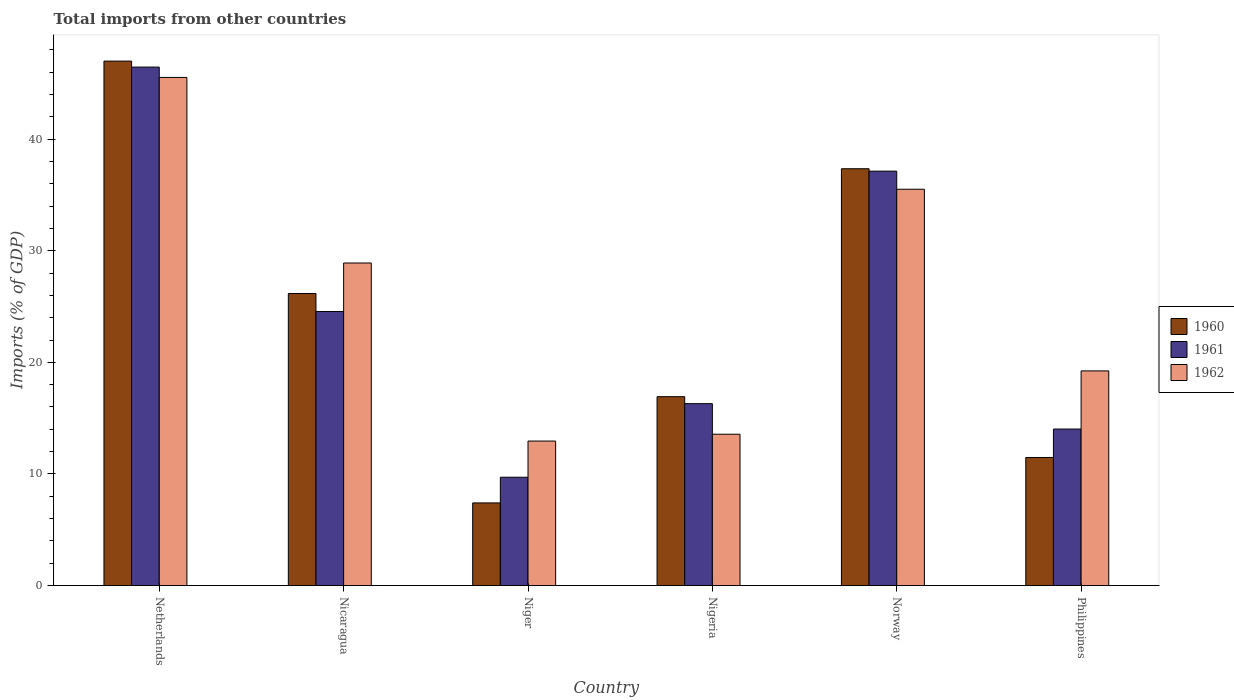What is the total imports in 1962 in Philippines?
Your answer should be very brief. 19.23. Across all countries, what is the maximum total imports in 1960?
Provide a short and direct response. 46.99. Across all countries, what is the minimum total imports in 1962?
Keep it short and to the point. 12.95. In which country was the total imports in 1961 minimum?
Provide a short and direct response. Niger. What is the total total imports in 1960 in the graph?
Your answer should be compact. 146.32. What is the difference between the total imports in 1962 in Nicaragua and that in Nigeria?
Provide a short and direct response. 15.34. What is the difference between the total imports in 1962 in Nigeria and the total imports in 1961 in Niger?
Keep it short and to the point. 3.86. What is the average total imports in 1960 per country?
Your answer should be very brief. 24.39. What is the difference between the total imports of/in 1962 and total imports of/in 1960 in Nicaragua?
Ensure brevity in your answer.  2.73. In how many countries, is the total imports in 1960 greater than 8 %?
Offer a very short reply. 5. What is the ratio of the total imports in 1962 in Nigeria to that in Philippines?
Your response must be concise. 0.7. Is the total imports in 1962 in Netherlands less than that in Nigeria?
Your answer should be compact. No. What is the difference between the highest and the second highest total imports in 1962?
Ensure brevity in your answer.  6.61. What is the difference between the highest and the lowest total imports in 1960?
Ensure brevity in your answer.  39.59. Is the sum of the total imports in 1962 in Nigeria and Norway greater than the maximum total imports in 1960 across all countries?
Make the answer very short. Yes. How many countries are there in the graph?
Your response must be concise. 6. Are the values on the major ticks of Y-axis written in scientific E-notation?
Give a very brief answer. No. Does the graph contain any zero values?
Provide a short and direct response. No. Does the graph contain grids?
Provide a short and direct response. No. How many legend labels are there?
Give a very brief answer. 3. What is the title of the graph?
Offer a terse response. Total imports from other countries. What is the label or title of the X-axis?
Ensure brevity in your answer.  Country. What is the label or title of the Y-axis?
Offer a very short reply. Imports (% of GDP). What is the Imports (% of GDP) in 1960 in Netherlands?
Ensure brevity in your answer.  46.99. What is the Imports (% of GDP) in 1961 in Netherlands?
Provide a succinct answer. 46.46. What is the Imports (% of GDP) of 1962 in Netherlands?
Offer a very short reply. 45.53. What is the Imports (% of GDP) of 1960 in Nicaragua?
Your answer should be very brief. 26.17. What is the Imports (% of GDP) in 1961 in Nicaragua?
Keep it short and to the point. 24.55. What is the Imports (% of GDP) in 1962 in Nicaragua?
Your answer should be compact. 28.9. What is the Imports (% of GDP) in 1960 in Niger?
Provide a succinct answer. 7.41. What is the Imports (% of GDP) in 1961 in Niger?
Offer a very short reply. 9.71. What is the Imports (% of GDP) of 1962 in Niger?
Give a very brief answer. 12.95. What is the Imports (% of GDP) of 1960 in Nigeria?
Give a very brief answer. 16.92. What is the Imports (% of GDP) in 1961 in Nigeria?
Offer a very short reply. 16.3. What is the Imports (% of GDP) in 1962 in Nigeria?
Make the answer very short. 13.56. What is the Imports (% of GDP) of 1960 in Norway?
Offer a very short reply. 37.35. What is the Imports (% of GDP) in 1961 in Norway?
Your answer should be very brief. 37.13. What is the Imports (% of GDP) in 1962 in Norway?
Offer a very short reply. 35.51. What is the Imports (% of GDP) in 1960 in Philippines?
Keep it short and to the point. 11.48. What is the Imports (% of GDP) of 1961 in Philippines?
Your answer should be compact. 14.02. What is the Imports (% of GDP) in 1962 in Philippines?
Your answer should be very brief. 19.23. Across all countries, what is the maximum Imports (% of GDP) in 1960?
Offer a terse response. 46.99. Across all countries, what is the maximum Imports (% of GDP) in 1961?
Offer a terse response. 46.46. Across all countries, what is the maximum Imports (% of GDP) in 1962?
Provide a short and direct response. 45.53. Across all countries, what is the minimum Imports (% of GDP) of 1960?
Provide a succinct answer. 7.41. Across all countries, what is the minimum Imports (% of GDP) in 1961?
Make the answer very short. 9.71. Across all countries, what is the minimum Imports (% of GDP) in 1962?
Provide a short and direct response. 12.95. What is the total Imports (% of GDP) of 1960 in the graph?
Keep it short and to the point. 146.32. What is the total Imports (% of GDP) in 1961 in the graph?
Provide a succinct answer. 148.17. What is the total Imports (% of GDP) of 1962 in the graph?
Offer a very short reply. 155.69. What is the difference between the Imports (% of GDP) in 1960 in Netherlands and that in Nicaragua?
Make the answer very short. 20.82. What is the difference between the Imports (% of GDP) of 1961 in Netherlands and that in Nicaragua?
Keep it short and to the point. 21.9. What is the difference between the Imports (% of GDP) in 1962 in Netherlands and that in Nicaragua?
Ensure brevity in your answer.  16.63. What is the difference between the Imports (% of GDP) in 1960 in Netherlands and that in Niger?
Ensure brevity in your answer.  39.59. What is the difference between the Imports (% of GDP) in 1961 in Netherlands and that in Niger?
Provide a short and direct response. 36.75. What is the difference between the Imports (% of GDP) of 1962 in Netherlands and that in Niger?
Ensure brevity in your answer.  32.58. What is the difference between the Imports (% of GDP) of 1960 in Netherlands and that in Nigeria?
Provide a succinct answer. 30.07. What is the difference between the Imports (% of GDP) in 1961 in Netherlands and that in Nigeria?
Provide a short and direct response. 30.16. What is the difference between the Imports (% of GDP) of 1962 in Netherlands and that in Nigeria?
Your answer should be compact. 31.97. What is the difference between the Imports (% of GDP) of 1960 in Netherlands and that in Norway?
Your answer should be very brief. 9.64. What is the difference between the Imports (% of GDP) of 1961 in Netherlands and that in Norway?
Keep it short and to the point. 9.32. What is the difference between the Imports (% of GDP) in 1962 in Netherlands and that in Norway?
Offer a very short reply. 10.02. What is the difference between the Imports (% of GDP) of 1960 in Netherlands and that in Philippines?
Offer a terse response. 35.52. What is the difference between the Imports (% of GDP) in 1961 in Netherlands and that in Philippines?
Provide a succinct answer. 32.43. What is the difference between the Imports (% of GDP) in 1962 in Netherlands and that in Philippines?
Offer a very short reply. 26.29. What is the difference between the Imports (% of GDP) in 1960 in Nicaragua and that in Niger?
Offer a very short reply. 18.76. What is the difference between the Imports (% of GDP) of 1961 in Nicaragua and that in Niger?
Give a very brief answer. 14.85. What is the difference between the Imports (% of GDP) of 1962 in Nicaragua and that in Niger?
Make the answer very short. 15.96. What is the difference between the Imports (% of GDP) of 1960 in Nicaragua and that in Nigeria?
Your answer should be compact. 9.24. What is the difference between the Imports (% of GDP) in 1961 in Nicaragua and that in Nigeria?
Keep it short and to the point. 8.25. What is the difference between the Imports (% of GDP) in 1962 in Nicaragua and that in Nigeria?
Your response must be concise. 15.34. What is the difference between the Imports (% of GDP) of 1960 in Nicaragua and that in Norway?
Offer a terse response. -11.18. What is the difference between the Imports (% of GDP) of 1961 in Nicaragua and that in Norway?
Your response must be concise. -12.58. What is the difference between the Imports (% of GDP) in 1962 in Nicaragua and that in Norway?
Provide a short and direct response. -6.61. What is the difference between the Imports (% of GDP) in 1960 in Nicaragua and that in Philippines?
Offer a terse response. 14.69. What is the difference between the Imports (% of GDP) of 1961 in Nicaragua and that in Philippines?
Keep it short and to the point. 10.53. What is the difference between the Imports (% of GDP) of 1962 in Nicaragua and that in Philippines?
Your answer should be very brief. 9.67. What is the difference between the Imports (% of GDP) in 1960 in Niger and that in Nigeria?
Make the answer very short. -9.52. What is the difference between the Imports (% of GDP) in 1961 in Niger and that in Nigeria?
Keep it short and to the point. -6.59. What is the difference between the Imports (% of GDP) in 1962 in Niger and that in Nigeria?
Offer a very short reply. -0.61. What is the difference between the Imports (% of GDP) in 1960 in Niger and that in Norway?
Your answer should be compact. -29.94. What is the difference between the Imports (% of GDP) of 1961 in Niger and that in Norway?
Provide a short and direct response. -27.43. What is the difference between the Imports (% of GDP) of 1962 in Niger and that in Norway?
Offer a terse response. -22.56. What is the difference between the Imports (% of GDP) of 1960 in Niger and that in Philippines?
Your answer should be very brief. -4.07. What is the difference between the Imports (% of GDP) in 1961 in Niger and that in Philippines?
Make the answer very short. -4.32. What is the difference between the Imports (% of GDP) in 1962 in Niger and that in Philippines?
Offer a very short reply. -6.29. What is the difference between the Imports (% of GDP) in 1960 in Nigeria and that in Norway?
Keep it short and to the point. -20.42. What is the difference between the Imports (% of GDP) in 1961 in Nigeria and that in Norway?
Give a very brief answer. -20.83. What is the difference between the Imports (% of GDP) of 1962 in Nigeria and that in Norway?
Your answer should be compact. -21.95. What is the difference between the Imports (% of GDP) of 1960 in Nigeria and that in Philippines?
Provide a short and direct response. 5.45. What is the difference between the Imports (% of GDP) in 1961 in Nigeria and that in Philippines?
Your answer should be compact. 2.27. What is the difference between the Imports (% of GDP) of 1962 in Nigeria and that in Philippines?
Your answer should be very brief. -5.67. What is the difference between the Imports (% of GDP) in 1960 in Norway and that in Philippines?
Your answer should be very brief. 25.87. What is the difference between the Imports (% of GDP) in 1961 in Norway and that in Philippines?
Ensure brevity in your answer.  23.11. What is the difference between the Imports (% of GDP) of 1962 in Norway and that in Philippines?
Keep it short and to the point. 16.28. What is the difference between the Imports (% of GDP) of 1960 in Netherlands and the Imports (% of GDP) of 1961 in Nicaragua?
Your answer should be very brief. 22.44. What is the difference between the Imports (% of GDP) in 1960 in Netherlands and the Imports (% of GDP) in 1962 in Nicaragua?
Your answer should be compact. 18.09. What is the difference between the Imports (% of GDP) of 1961 in Netherlands and the Imports (% of GDP) of 1962 in Nicaragua?
Your answer should be compact. 17.55. What is the difference between the Imports (% of GDP) in 1960 in Netherlands and the Imports (% of GDP) in 1961 in Niger?
Your answer should be compact. 37.29. What is the difference between the Imports (% of GDP) in 1960 in Netherlands and the Imports (% of GDP) in 1962 in Niger?
Give a very brief answer. 34.05. What is the difference between the Imports (% of GDP) of 1961 in Netherlands and the Imports (% of GDP) of 1962 in Niger?
Provide a short and direct response. 33.51. What is the difference between the Imports (% of GDP) of 1960 in Netherlands and the Imports (% of GDP) of 1961 in Nigeria?
Your answer should be very brief. 30.69. What is the difference between the Imports (% of GDP) in 1960 in Netherlands and the Imports (% of GDP) in 1962 in Nigeria?
Offer a very short reply. 33.43. What is the difference between the Imports (% of GDP) of 1961 in Netherlands and the Imports (% of GDP) of 1962 in Nigeria?
Keep it short and to the point. 32.9. What is the difference between the Imports (% of GDP) of 1960 in Netherlands and the Imports (% of GDP) of 1961 in Norway?
Your answer should be compact. 9.86. What is the difference between the Imports (% of GDP) of 1960 in Netherlands and the Imports (% of GDP) of 1962 in Norway?
Keep it short and to the point. 11.48. What is the difference between the Imports (% of GDP) of 1961 in Netherlands and the Imports (% of GDP) of 1962 in Norway?
Your response must be concise. 10.94. What is the difference between the Imports (% of GDP) of 1960 in Netherlands and the Imports (% of GDP) of 1961 in Philippines?
Ensure brevity in your answer.  32.97. What is the difference between the Imports (% of GDP) in 1960 in Netherlands and the Imports (% of GDP) in 1962 in Philippines?
Ensure brevity in your answer.  27.76. What is the difference between the Imports (% of GDP) of 1961 in Netherlands and the Imports (% of GDP) of 1962 in Philippines?
Your answer should be very brief. 27.22. What is the difference between the Imports (% of GDP) of 1960 in Nicaragua and the Imports (% of GDP) of 1961 in Niger?
Make the answer very short. 16.46. What is the difference between the Imports (% of GDP) in 1960 in Nicaragua and the Imports (% of GDP) in 1962 in Niger?
Offer a very short reply. 13.22. What is the difference between the Imports (% of GDP) in 1961 in Nicaragua and the Imports (% of GDP) in 1962 in Niger?
Your response must be concise. 11.61. What is the difference between the Imports (% of GDP) of 1960 in Nicaragua and the Imports (% of GDP) of 1961 in Nigeria?
Offer a very short reply. 9.87. What is the difference between the Imports (% of GDP) of 1960 in Nicaragua and the Imports (% of GDP) of 1962 in Nigeria?
Offer a terse response. 12.61. What is the difference between the Imports (% of GDP) of 1961 in Nicaragua and the Imports (% of GDP) of 1962 in Nigeria?
Offer a terse response. 10.99. What is the difference between the Imports (% of GDP) of 1960 in Nicaragua and the Imports (% of GDP) of 1961 in Norway?
Your answer should be compact. -10.96. What is the difference between the Imports (% of GDP) in 1960 in Nicaragua and the Imports (% of GDP) in 1962 in Norway?
Make the answer very short. -9.34. What is the difference between the Imports (% of GDP) of 1961 in Nicaragua and the Imports (% of GDP) of 1962 in Norway?
Keep it short and to the point. -10.96. What is the difference between the Imports (% of GDP) of 1960 in Nicaragua and the Imports (% of GDP) of 1961 in Philippines?
Provide a succinct answer. 12.14. What is the difference between the Imports (% of GDP) of 1960 in Nicaragua and the Imports (% of GDP) of 1962 in Philippines?
Make the answer very short. 6.93. What is the difference between the Imports (% of GDP) in 1961 in Nicaragua and the Imports (% of GDP) in 1962 in Philippines?
Your answer should be very brief. 5.32. What is the difference between the Imports (% of GDP) of 1960 in Niger and the Imports (% of GDP) of 1961 in Nigeria?
Your answer should be very brief. -8.89. What is the difference between the Imports (% of GDP) of 1960 in Niger and the Imports (% of GDP) of 1962 in Nigeria?
Keep it short and to the point. -6.16. What is the difference between the Imports (% of GDP) of 1961 in Niger and the Imports (% of GDP) of 1962 in Nigeria?
Ensure brevity in your answer.  -3.85. What is the difference between the Imports (% of GDP) of 1960 in Niger and the Imports (% of GDP) of 1961 in Norway?
Make the answer very short. -29.73. What is the difference between the Imports (% of GDP) of 1960 in Niger and the Imports (% of GDP) of 1962 in Norway?
Make the answer very short. -28.11. What is the difference between the Imports (% of GDP) in 1961 in Niger and the Imports (% of GDP) in 1962 in Norway?
Make the answer very short. -25.81. What is the difference between the Imports (% of GDP) of 1960 in Niger and the Imports (% of GDP) of 1961 in Philippines?
Your answer should be compact. -6.62. What is the difference between the Imports (% of GDP) in 1960 in Niger and the Imports (% of GDP) in 1962 in Philippines?
Keep it short and to the point. -11.83. What is the difference between the Imports (% of GDP) of 1961 in Niger and the Imports (% of GDP) of 1962 in Philippines?
Ensure brevity in your answer.  -9.53. What is the difference between the Imports (% of GDP) in 1960 in Nigeria and the Imports (% of GDP) in 1961 in Norway?
Keep it short and to the point. -20.21. What is the difference between the Imports (% of GDP) in 1960 in Nigeria and the Imports (% of GDP) in 1962 in Norway?
Your response must be concise. -18.59. What is the difference between the Imports (% of GDP) in 1961 in Nigeria and the Imports (% of GDP) in 1962 in Norway?
Give a very brief answer. -19.21. What is the difference between the Imports (% of GDP) of 1960 in Nigeria and the Imports (% of GDP) of 1961 in Philippines?
Give a very brief answer. 2.9. What is the difference between the Imports (% of GDP) in 1960 in Nigeria and the Imports (% of GDP) in 1962 in Philippines?
Provide a succinct answer. -2.31. What is the difference between the Imports (% of GDP) in 1961 in Nigeria and the Imports (% of GDP) in 1962 in Philippines?
Give a very brief answer. -2.93. What is the difference between the Imports (% of GDP) in 1960 in Norway and the Imports (% of GDP) in 1961 in Philippines?
Your answer should be compact. 23.32. What is the difference between the Imports (% of GDP) in 1960 in Norway and the Imports (% of GDP) in 1962 in Philippines?
Provide a short and direct response. 18.11. What is the difference between the Imports (% of GDP) of 1961 in Norway and the Imports (% of GDP) of 1962 in Philippines?
Provide a succinct answer. 17.9. What is the average Imports (% of GDP) in 1960 per country?
Your response must be concise. 24.39. What is the average Imports (% of GDP) in 1961 per country?
Offer a very short reply. 24.7. What is the average Imports (% of GDP) in 1962 per country?
Your answer should be very brief. 25.95. What is the difference between the Imports (% of GDP) of 1960 and Imports (% of GDP) of 1961 in Netherlands?
Your answer should be very brief. 0.54. What is the difference between the Imports (% of GDP) of 1960 and Imports (% of GDP) of 1962 in Netherlands?
Keep it short and to the point. 1.46. What is the difference between the Imports (% of GDP) in 1961 and Imports (% of GDP) in 1962 in Netherlands?
Give a very brief answer. 0.93. What is the difference between the Imports (% of GDP) of 1960 and Imports (% of GDP) of 1961 in Nicaragua?
Your answer should be very brief. 1.62. What is the difference between the Imports (% of GDP) in 1960 and Imports (% of GDP) in 1962 in Nicaragua?
Your answer should be very brief. -2.73. What is the difference between the Imports (% of GDP) in 1961 and Imports (% of GDP) in 1962 in Nicaragua?
Give a very brief answer. -4.35. What is the difference between the Imports (% of GDP) of 1960 and Imports (% of GDP) of 1962 in Niger?
Your response must be concise. -5.54. What is the difference between the Imports (% of GDP) in 1961 and Imports (% of GDP) in 1962 in Niger?
Your answer should be very brief. -3.24. What is the difference between the Imports (% of GDP) of 1960 and Imports (% of GDP) of 1961 in Nigeria?
Your answer should be compact. 0.63. What is the difference between the Imports (% of GDP) in 1960 and Imports (% of GDP) in 1962 in Nigeria?
Ensure brevity in your answer.  3.36. What is the difference between the Imports (% of GDP) of 1961 and Imports (% of GDP) of 1962 in Nigeria?
Keep it short and to the point. 2.74. What is the difference between the Imports (% of GDP) of 1960 and Imports (% of GDP) of 1961 in Norway?
Make the answer very short. 0.22. What is the difference between the Imports (% of GDP) in 1960 and Imports (% of GDP) in 1962 in Norway?
Offer a very short reply. 1.84. What is the difference between the Imports (% of GDP) of 1961 and Imports (% of GDP) of 1962 in Norway?
Make the answer very short. 1.62. What is the difference between the Imports (% of GDP) in 1960 and Imports (% of GDP) in 1961 in Philippines?
Offer a terse response. -2.55. What is the difference between the Imports (% of GDP) in 1960 and Imports (% of GDP) in 1962 in Philippines?
Keep it short and to the point. -7.76. What is the difference between the Imports (% of GDP) of 1961 and Imports (% of GDP) of 1962 in Philippines?
Your answer should be very brief. -5.21. What is the ratio of the Imports (% of GDP) in 1960 in Netherlands to that in Nicaragua?
Your answer should be very brief. 1.8. What is the ratio of the Imports (% of GDP) in 1961 in Netherlands to that in Nicaragua?
Offer a very short reply. 1.89. What is the ratio of the Imports (% of GDP) of 1962 in Netherlands to that in Nicaragua?
Offer a terse response. 1.58. What is the ratio of the Imports (% of GDP) of 1960 in Netherlands to that in Niger?
Keep it short and to the point. 6.35. What is the ratio of the Imports (% of GDP) of 1961 in Netherlands to that in Niger?
Offer a very short reply. 4.79. What is the ratio of the Imports (% of GDP) in 1962 in Netherlands to that in Niger?
Give a very brief answer. 3.52. What is the ratio of the Imports (% of GDP) of 1960 in Netherlands to that in Nigeria?
Offer a very short reply. 2.78. What is the ratio of the Imports (% of GDP) of 1961 in Netherlands to that in Nigeria?
Provide a short and direct response. 2.85. What is the ratio of the Imports (% of GDP) in 1962 in Netherlands to that in Nigeria?
Keep it short and to the point. 3.36. What is the ratio of the Imports (% of GDP) of 1960 in Netherlands to that in Norway?
Keep it short and to the point. 1.26. What is the ratio of the Imports (% of GDP) in 1961 in Netherlands to that in Norway?
Make the answer very short. 1.25. What is the ratio of the Imports (% of GDP) of 1962 in Netherlands to that in Norway?
Provide a short and direct response. 1.28. What is the ratio of the Imports (% of GDP) in 1960 in Netherlands to that in Philippines?
Your answer should be compact. 4.1. What is the ratio of the Imports (% of GDP) of 1961 in Netherlands to that in Philippines?
Provide a succinct answer. 3.31. What is the ratio of the Imports (% of GDP) of 1962 in Netherlands to that in Philippines?
Make the answer very short. 2.37. What is the ratio of the Imports (% of GDP) in 1960 in Nicaragua to that in Niger?
Provide a short and direct response. 3.53. What is the ratio of the Imports (% of GDP) in 1961 in Nicaragua to that in Niger?
Give a very brief answer. 2.53. What is the ratio of the Imports (% of GDP) of 1962 in Nicaragua to that in Niger?
Make the answer very short. 2.23. What is the ratio of the Imports (% of GDP) in 1960 in Nicaragua to that in Nigeria?
Provide a succinct answer. 1.55. What is the ratio of the Imports (% of GDP) of 1961 in Nicaragua to that in Nigeria?
Provide a short and direct response. 1.51. What is the ratio of the Imports (% of GDP) of 1962 in Nicaragua to that in Nigeria?
Give a very brief answer. 2.13. What is the ratio of the Imports (% of GDP) of 1960 in Nicaragua to that in Norway?
Your answer should be very brief. 0.7. What is the ratio of the Imports (% of GDP) in 1961 in Nicaragua to that in Norway?
Your answer should be very brief. 0.66. What is the ratio of the Imports (% of GDP) of 1962 in Nicaragua to that in Norway?
Your answer should be compact. 0.81. What is the ratio of the Imports (% of GDP) in 1960 in Nicaragua to that in Philippines?
Give a very brief answer. 2.28. What is the ratio of the Imports (% of GDP) of 1961 in Nicaragua to that in Philippines?
Your answer should be compact. 1.75. What is the ratio of the Imports (% of GDP) of 1962 in Nicaragua to that in Philippines?
Provide a succinct answer. 1.5. What is the ratio of the Imports (% of GDP) in 1960 in Niger to that in Nigeria?
Your answer should be very brief. 0.44. What is the ratio of the Imports (% of GDP) of 1961 in Niger to that in Nigeria?
Offer a terse response. 0.6. What is the ratio of the Imports (% of GDP) in 1962 in Niger to that in Nigeria?
Provide a short and direct response. 0.95. What is the ratio of the Imports (% of GDP) in 1960 in Niger to that in Norway?
Provide a succinct answer. 0.2. What is the ratio of the Imports (% of GDP) of 1961 in Niger to that in Norway?
Ensure brevity in your answer.  0.26. What is the ratio of the Imports (% of GDP) of 1962 in Niger to that in Norway?
Provide a short and direct response. 0.36. What is the ratio of the Imports (% of GDP) in 1960 in Niger to that in Philippines?
Your response must be concise. 0.65. What is the ratio of the Imports (% of GDP) of 1961 in Niger to that in Philippines?
Provide a short and direct response. 0.69. What is the ratio of the Imports (% of GDP) in 1962 in Niger to that in Philippines?
Make the answer very short. 0.67. What is the ratio of the Imports (% of GDP) of 1960 in Nigeria to that in Norway?
Offer a very short reply. 0.45. What is the ratio of the Imports (% of GDP) in 1961 in Nigeria to that in Norway?
Provide a short and direct response. 0.44. What is the ratio of the Imports (% of GDP) in 1962 in Nigeria to that in Norway?
Give a very brief answer. 0.38. What is the ratio of the Imports (% of GDP) of 1960 in Nigeria to that in Philippines?
Your answer should be compact. 1.47. What is the ratio of the Imports (% of GDP) in 1961 in Nigeria to that in Philippines?
Provide a short and direct response. 1.16. What is the ratio of the Imports (% of GDP) in 1962 in Nigeria to that in Philippines?
Make the answer very short. 0.7. What is the ratio of the Imports (% of GDP) in 1960 in Norway to that in Philippines?
Offer a very short reply. 3.25. What is the ratio of the Imports (% of GDP) of 1961 in Norway to that in Philippines?
Offer a very short reply. 2.65. What is the ratio of the Imports (% of GDP) of 1962 in Norway to that in Philippines?
Offer a very short reply. 1.85. What is the difference between the highest and the second highest Imports (% of GDP) of 1960?
Make the answer very short. 9.64. What is the difference between the highest and the second highest Imports (% of GDP) in 1961?
Make the answer very short. 9.32. What is the difference between the highest and the second highest Imports (% of GDP) of 1962?
Your answer should be very brief. 10.02. What is the difference between the highest and the lowest Imports (% of GDP) of 1960?
Ensure brevity in your answer.  39.59. What is the difference between the highest and the lowest Imports (% of GDP) in 1961?
Offer a terse response. 36.75. What is the difference between the highest and the lowest Imports (% of GDP) in 1962?
Your response must be concise. 32.58. 